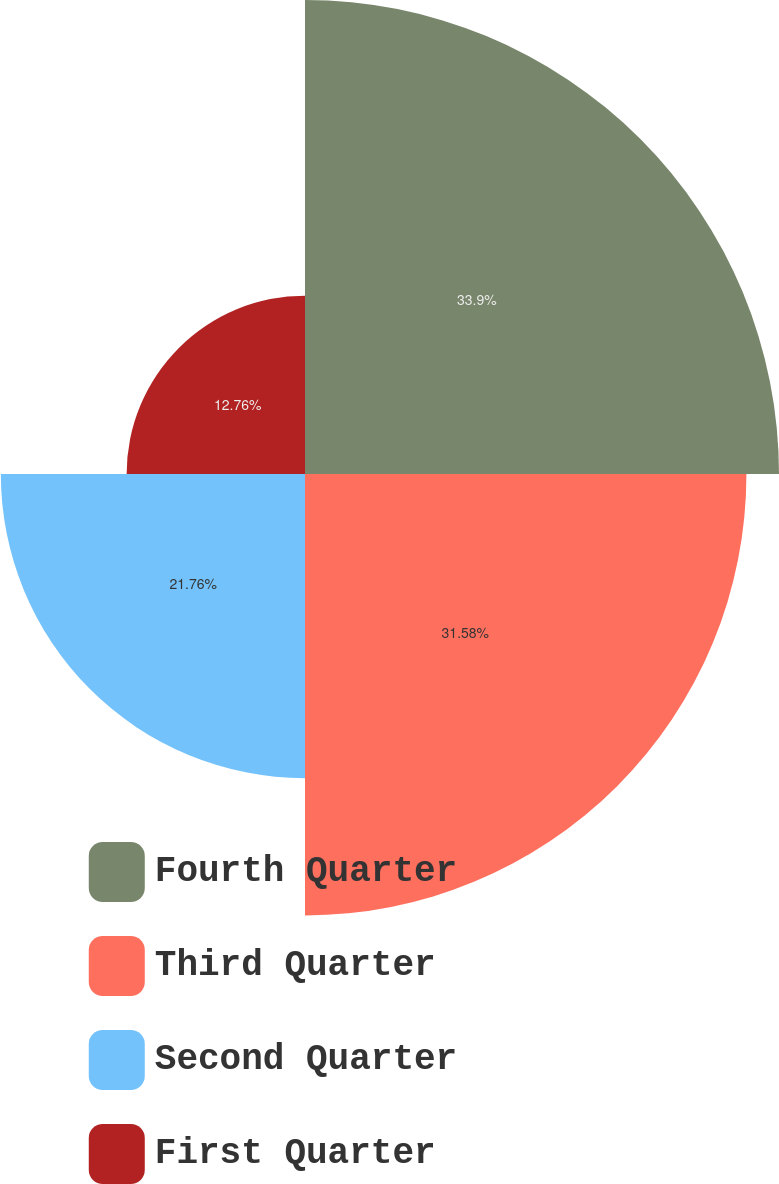Convert chart. <chart><loc_0><loc_0><loc_500><loc_500><pie_chart><fcel>Fourth Quarter<fcel>Third Quarter<fcel>Second Quarter<fcel>First Quarter<nl><fcel>33.91%<fcel>31.58%<fcel>21.76%<fcel>12.76%<nl></chart> 